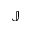Convert formula to latex. <formula><loc_0><loc_0><loc_500><loc_500>\mathbb { J }</formula> 